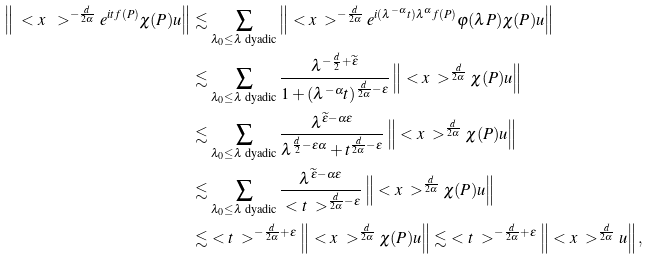<formula> <loc_0><loc_0><loc_500><loc_500>\left \| \ < x \ > ^ { - \frac { d } { 2 \alpha } } e ^ { i t f ( P ) } \chi ( P ) u \right \| & \lesssim \sum _ { \lambda _ { 0 } \leq \lambda \text { dyadic} } \left \| \ < x \ > ^ { - \frac { d } { 2 \alpha } } e ^ { i ( \lambda ^ { - \alpha } t ) \lambda ^ { \alpha } f ( P ) } \varphi ( \lambda P ) \chi ( P ) u \right \| \\ & \lesssim \sum _ { \lambda _ { 0 } \leq \lambda \text { dyadic} } \frac { \lambda ^ { - \frac { d } { 2 } + \widetilde { \varepsilon } } } { 1 + ( \lambda ^ { - \alpha } t ) ^ { \frac { d } { 2 \alpha } - \varepsilon } } \left \| \ < x \ > ^ { \frac { d } { 2 \alpha } } \chi ( P ) u \right \| \\ & \lesssim \sum _ { \lambda _ { 0 } \leq \lambda \text { dyadic} } \frac { \lambda ^ { \widetilde { \varepsilon } - \alpha \varepsilon } } { \lambda ^ { \frac { d } { 2 } - \varepsilon \alpha } + t ^ { \frac { d } { 2 \alpha } - \varepsilon } } \left \| \ < x \ > ^ { \frac { d } { 2 \alpha } } \chi ( P ) u \right \| \\ & \lesssim \sum _ { \lambda _ { 0 } \leq \lambda \text { dyadic} } \frac { \lambda ^ { \widetilde { \varepsilon } - \alpha \varepsilon } } { \ < t \ > ^ { \frac { d } { 2 \alpha } - \varepsilon } } \left \| \ < x \ > ^ { \frac { d } { 2 \alpha } } \chi ( P ) u \right \| \\ & \lesssim \ < t \ > ^ { - \frac { d } { 2 \alpha } + \varepsilon } \left \| \ < x \ > ^ { \frac { d } { 2 \alpha } } \chi ( P ) u \right \| \lesssim \ < t \ > ^ { - \frac { d } { 2 \alpha } + \varepsilon } \left \| \ < x \ > ^ { \frac { d } { 2 \alpha } } u \right \| ,</formula> 